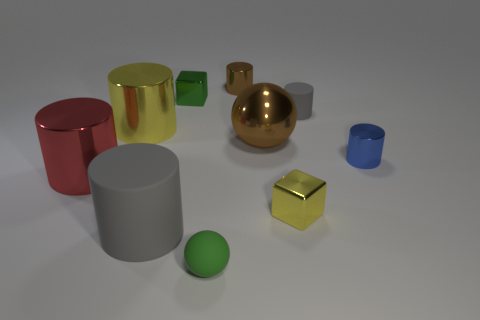Do the tiny object right of the tiny rubber cylinder and the small matte object that is on the right side of the tiny brown metallic object have the same shape?
Your answer should be very brief. Yes. What number of objects are gray cylinders or large cylinders that are behind the large red cylinder?
Your response must be concise. 3. How many other things are the same size as the yellow metal block?
Your response must be concise. 5. Do the big red object behind the large gray matte object and the gray cylinder that is in front of the big red thing have the same material?
Your answer should be compact. No. How many yellow cylinders are in front of the matte ball?
Ensure brevity in your answer.  0. What number of green objects are either tiny balls or tiny shiny blocks?
Give a very brief answer. 2. What material is the cube that is the same size as the green shiny object?
Give a very brief answer. Metal. There is a rubber object that is both in front of the big red shiny thing and behind the small matte ball; what is its shape?
Your answer should be very brief. Cylinder. There is a shiny cylinder that is the same size as the red metallic thing; what color is it?
Your answer should be compact. Yellow. There is a metallic cube in front of the red thing; is it the same size as the rubber thing that is behind the blue cylinder?
Your answer should be very brief. Yes. 